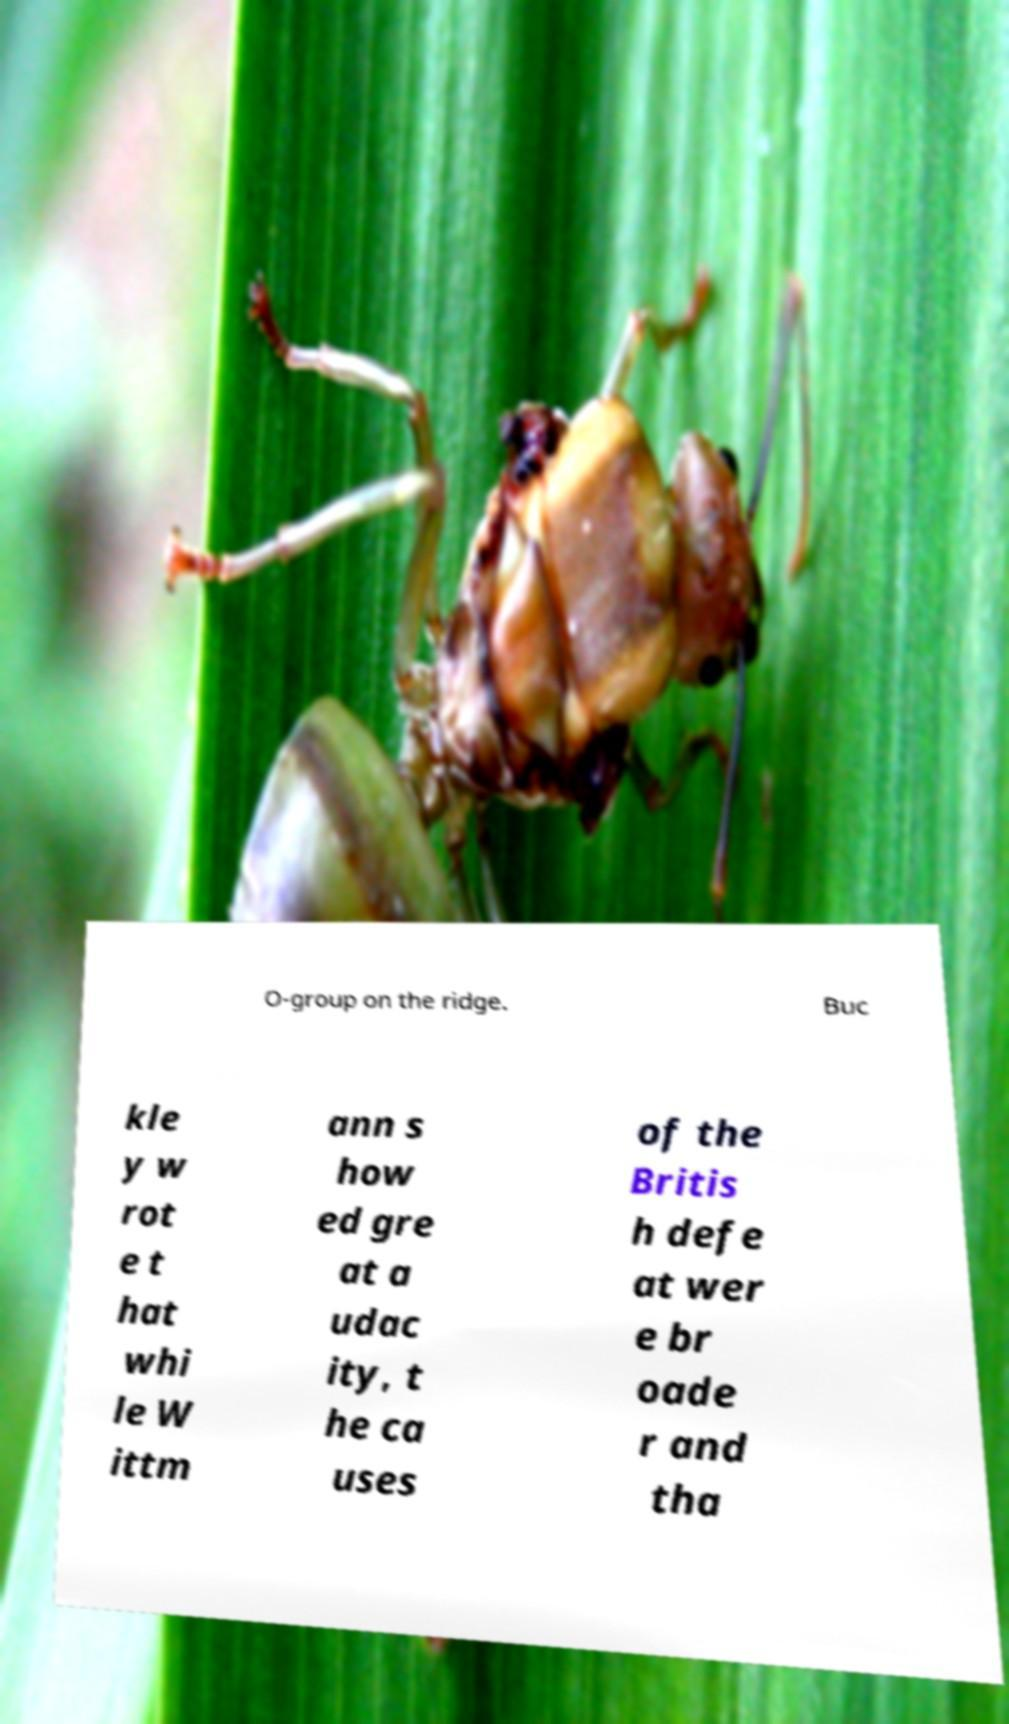For documentation purposes, I need the text within this image transcribed. Could you provide that? O-group on the ridge. Buc kle y w rot e t hat whi le W ittm ann s how ed gre at a udac ity, t he ca uses of the Britis h defe at wer e br oade r and tha 